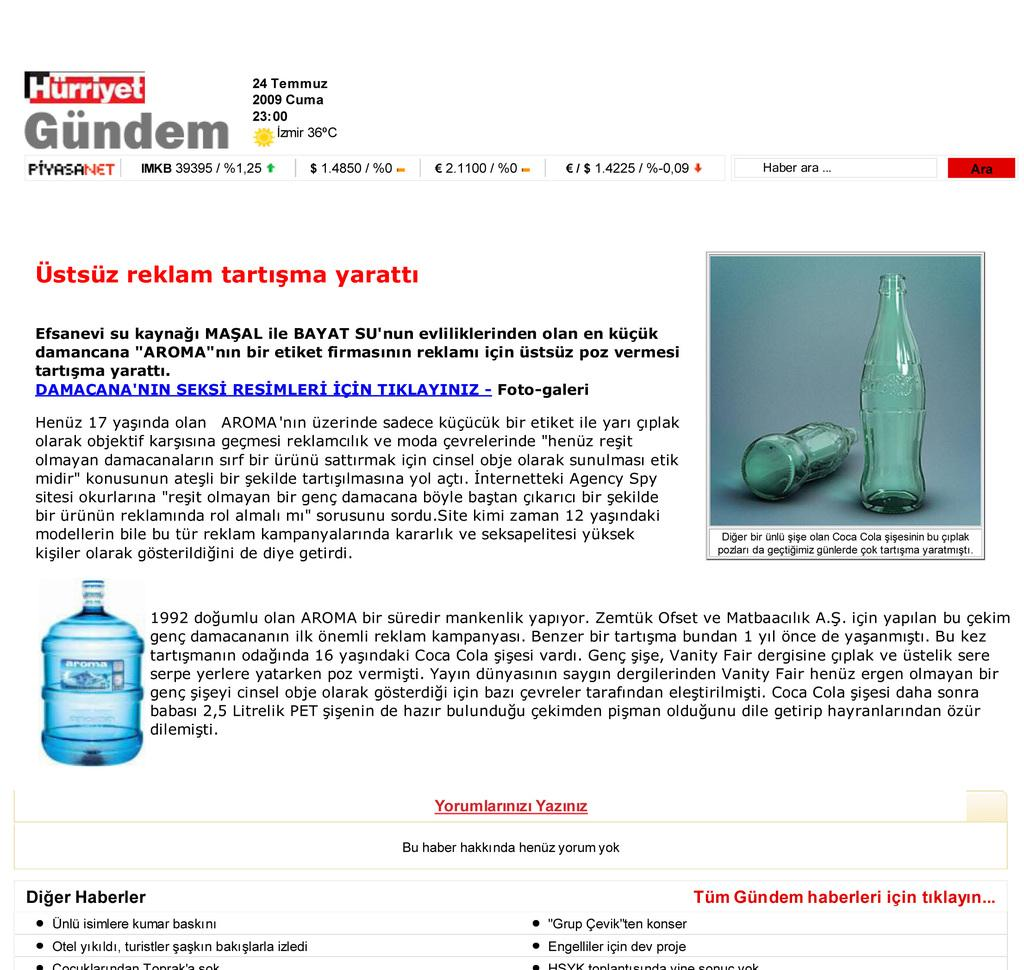<image>
Create a compact narrative representing the image presented. An advertisement has the word Hurriyet at the top of the page. 